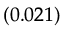Convert formula to latex. <formula><loc_0><loc_0><loc_500><loc_500>_ { ( 0 . 0 2 1 ) }</formula> 